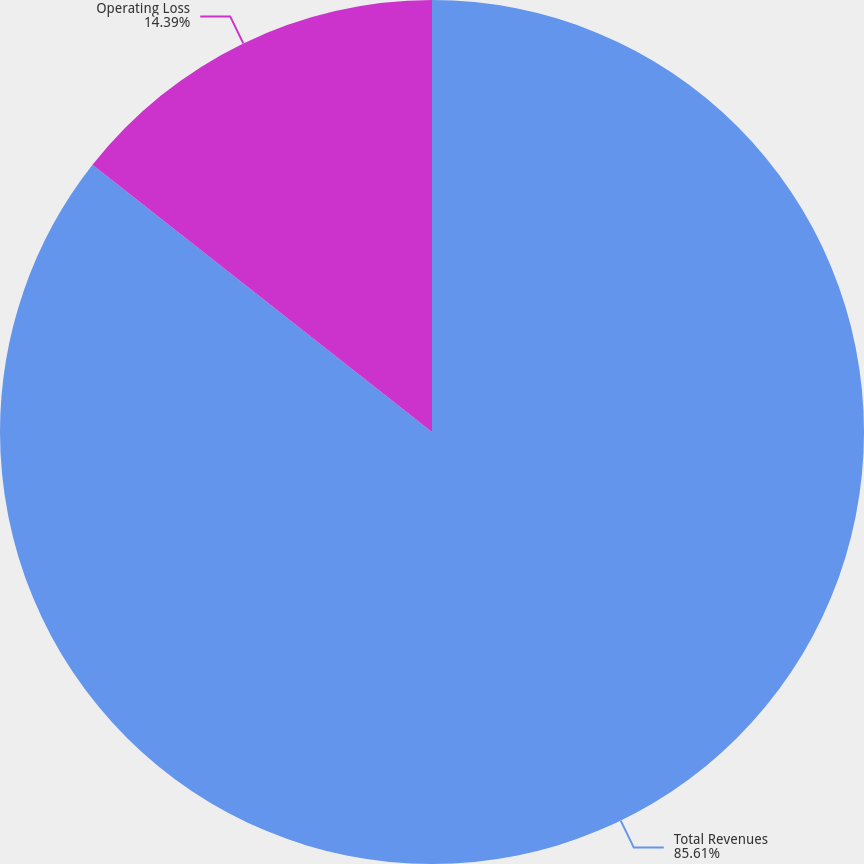<chart> <loc_0><loc_0><loc_500><loc_500><pie_chart><fcel>Total Revenues<fcel>Operating Loss<nl><fcel>85.61%<fcel>14.39%<nl></chart> 